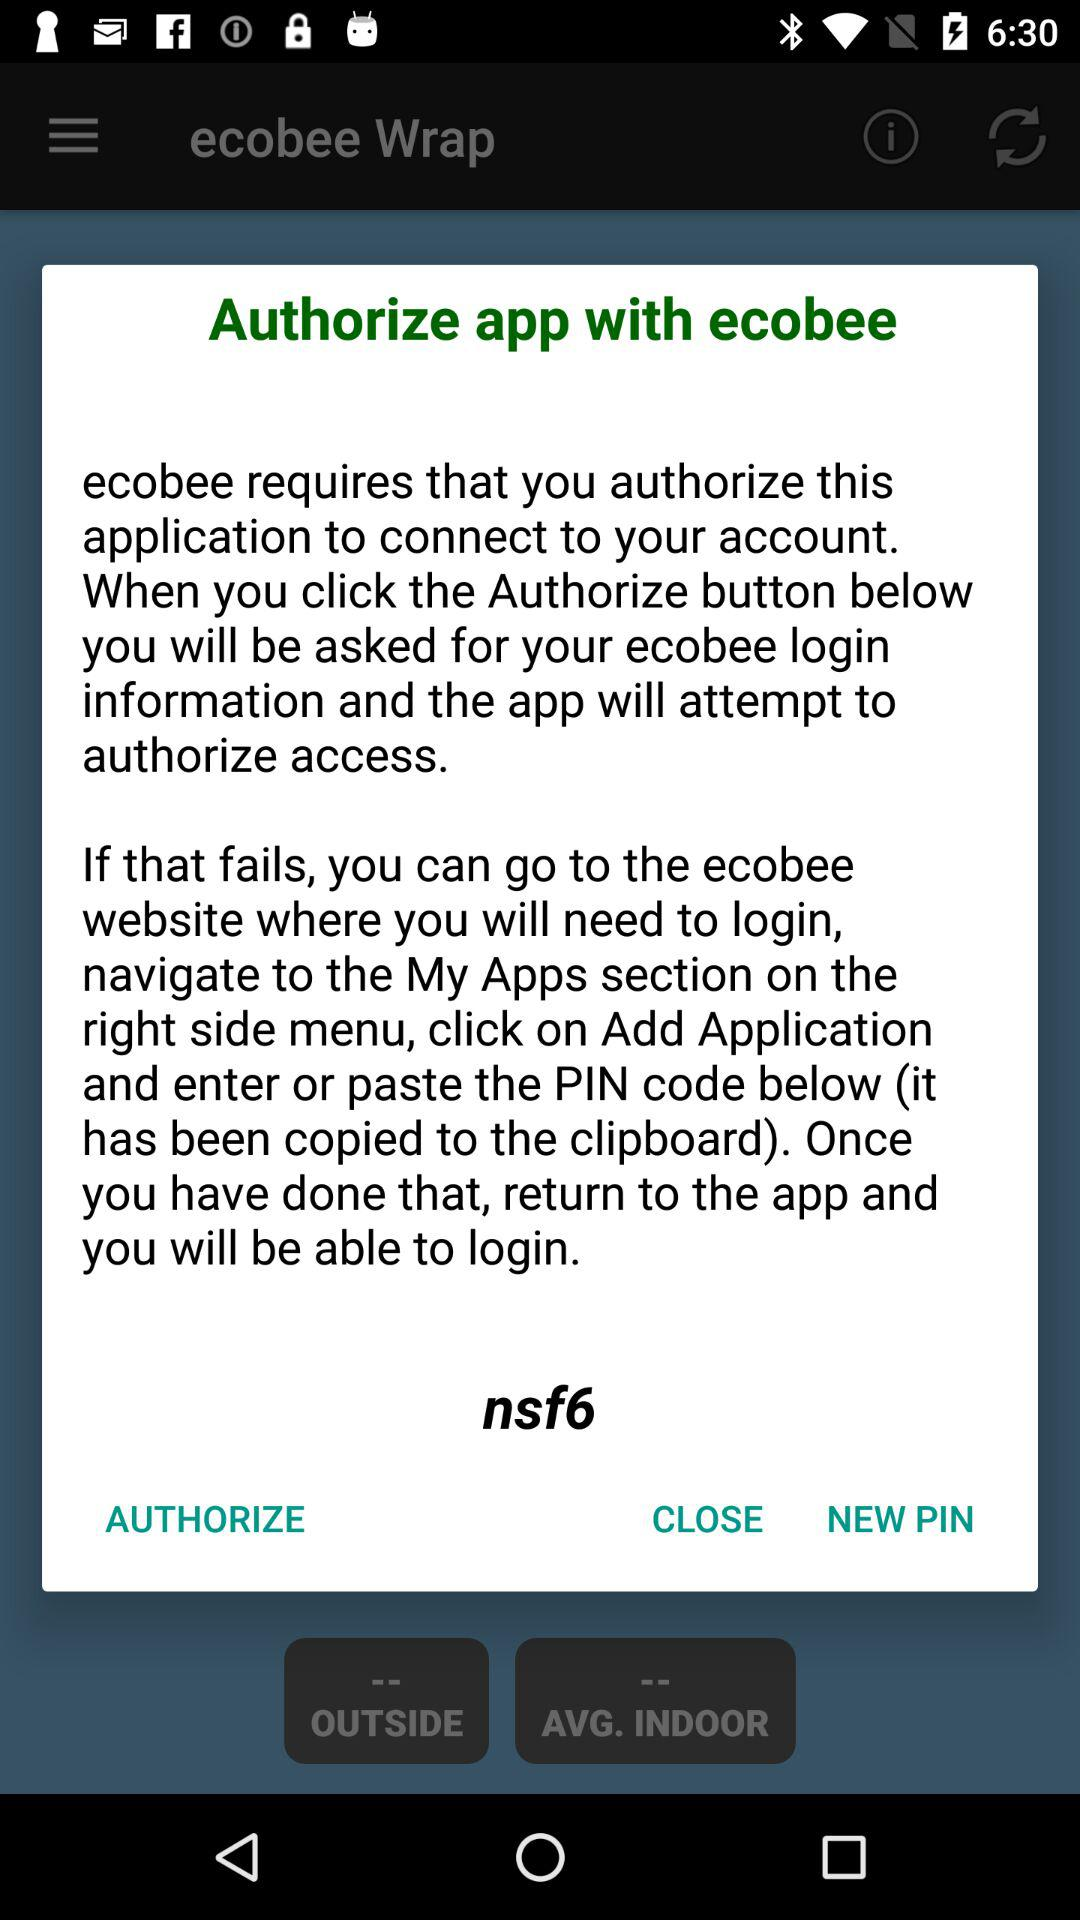What is the name of application? The name of application is "ecobee Wrap". 